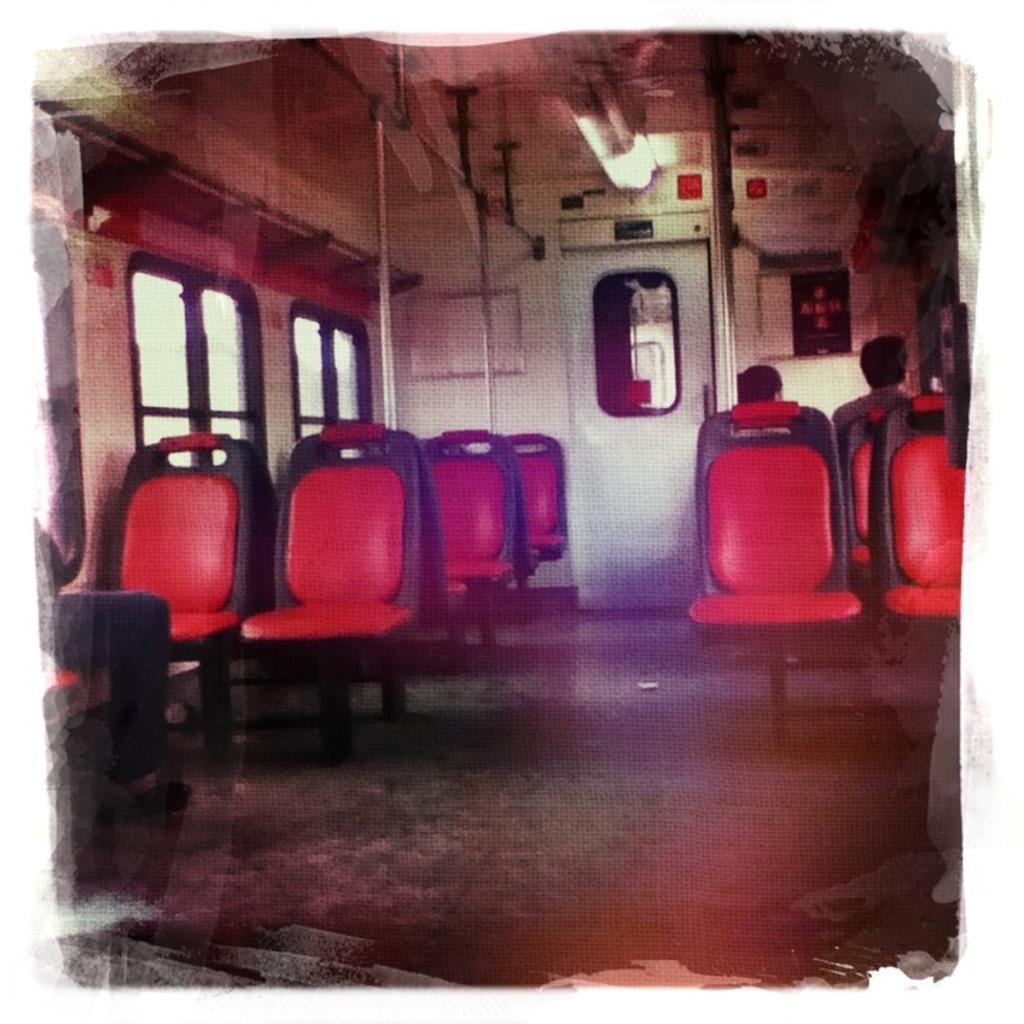Describe this image in one or two sentences. this is an inside view picture of a vehicle. At the top we can see lights. This is a door. Here we can see chairs. These are windows. 